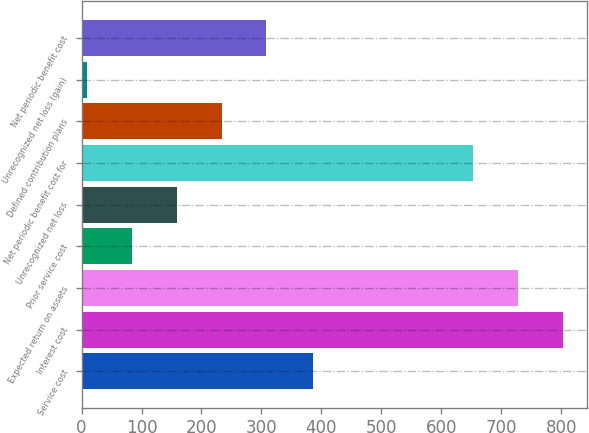Convert chart to OTSL. <chart><loc_0><loc_0><loc_500><loc_500><bar_chart><fcel>Service cost<fcel>Interest cost<fcel>Expected return on assets<fcel>Prior service cost<fcel>Unrecognized net loss<fcel>Net periodic benefit cost for<fcel>Defined contribution plans<fcel>Unrecognized net loss (gain)<fcel>Net periodic benefit cost<nl><fcel>386<fcel>802.6<fcel>727.8<fcel>83.8<fcel>158.6<fcel>653<fcel>233.4<fcel>9<fcel>308.2<nl></chart> 